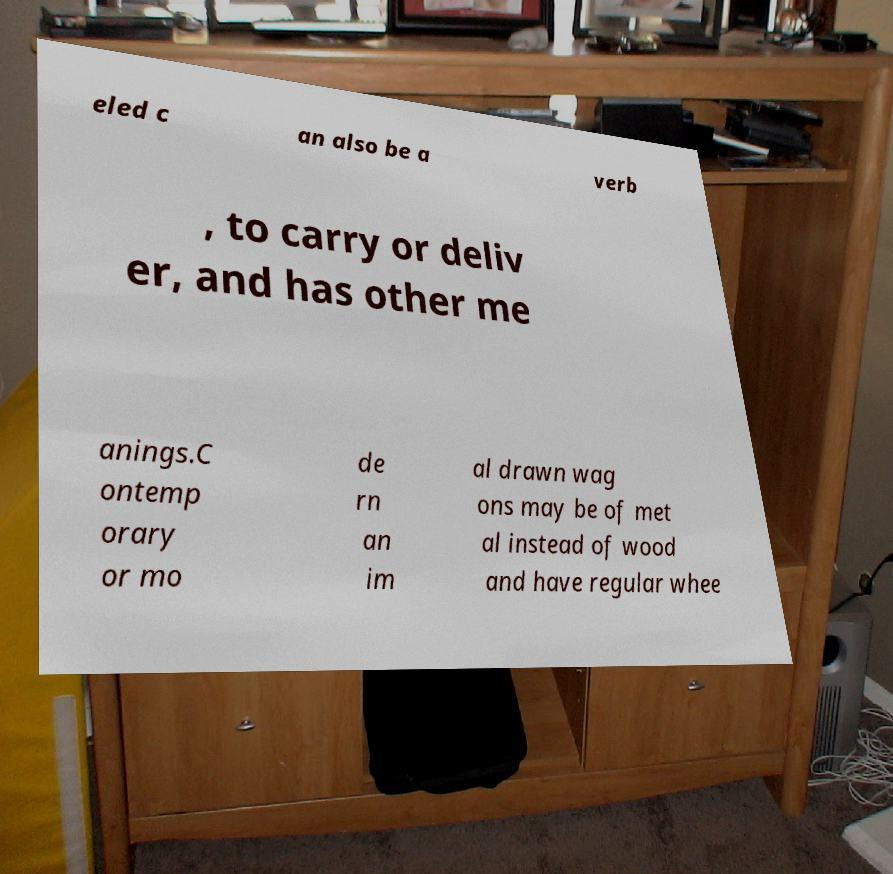Could you assist in decoding the text presented in this image and type it out clearly? eled c an also be a verb , to carry or deliv er, and has other me anings.C ontemp orary or mo de rn an im al drawn wag ons may be of met al instead of wood and have regular whee 